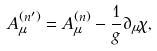<formula> <loc_0><loc_0><loc_500><loc_500>A ^ { ( n ^ { \prime } ) } _ { \mu } = A ^ { ( n ) } _ { \mu } - \frac { 1 } { g } \partial _ { \mu } \chi ,</formula> 